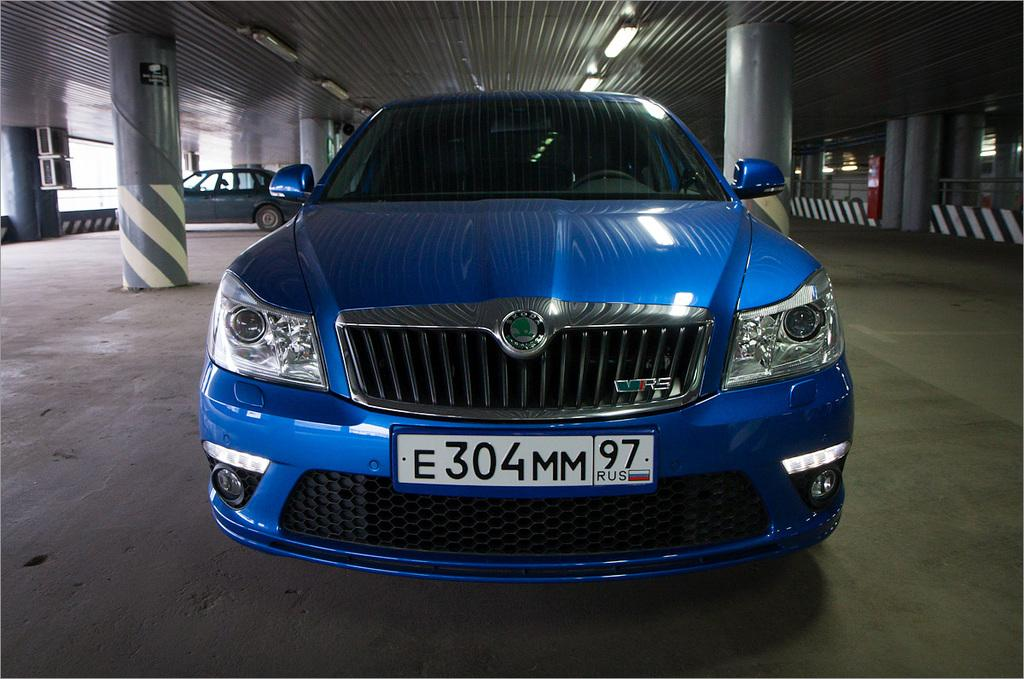What is the main subject in the middle of the image? There is a blue color vehicle in the middle of the image. Where is the blue vehicle located? The blue vehicle is on the floor. What else can be seen in the image besides the blue vehicle? There is another vehicle and pillars in the background of the image, as well as lights attached to a roof. What type of watch can be seen on the blue vehicle in the image? There is no watch visible on the blue vehicle in the image. What shape is the cloud in the image? There is no cloud present in the image. 